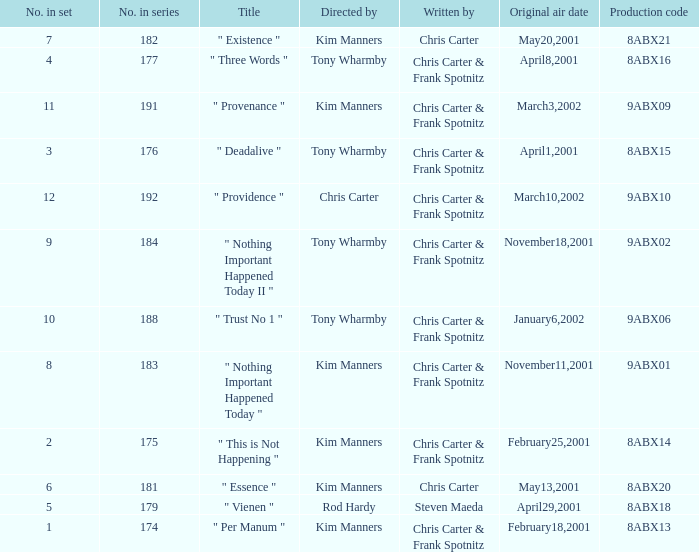What is the episode number that has production code 8abx15? 176.0. 